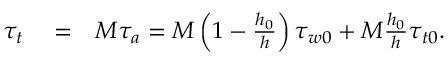Convert formula to latex. <formula><loc_0><loc_0><loc_500><loc_500>\begin{array} { r l r } { \tau _ { t } } & = } & { M \tau _ { a } = M \left ( 1 - \frac { h _ { 0 } } { h } \right ) \tau _ { w 0 } + M \frac { h _ { 0 } } { h } \tau _ { t 0 } . } \end{array}</formula> 